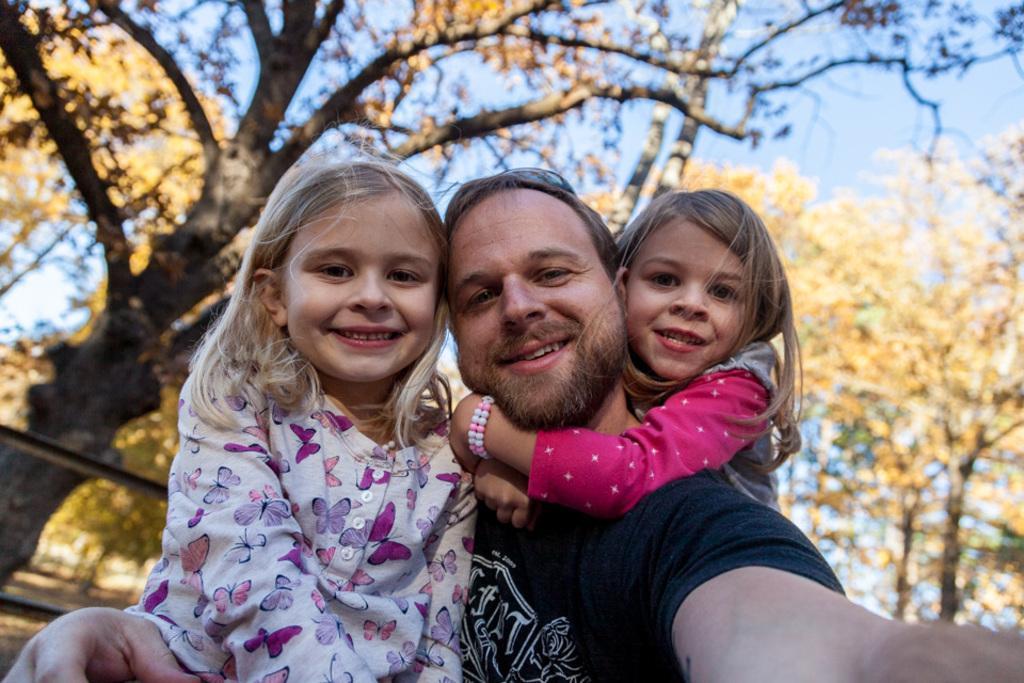Describe this image in one or two sentences. In this picture there is men and two kids taking selfie in the background there are trees. 